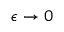<formula> <loc_0><loc_0><loc_500><loc_500>\epsilon \rightarrow 0</formula> 